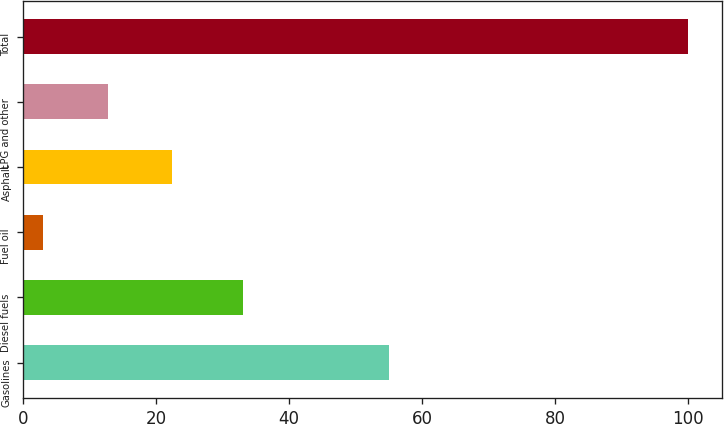Convert chart to OTSL. <chart><loc_0><loc_0><loc_500><loc_500><bar_chart><fcel>Gasolines<fcel>Diesel fuels<fcel>Fuel oil<fcel>Asphalt<fcel>LPG and other<fcel>Total<nl><fcel>55<fcel>33<fcel>3<fcel>22.4<fcel>12.7<fcel>100<nl></chart> 